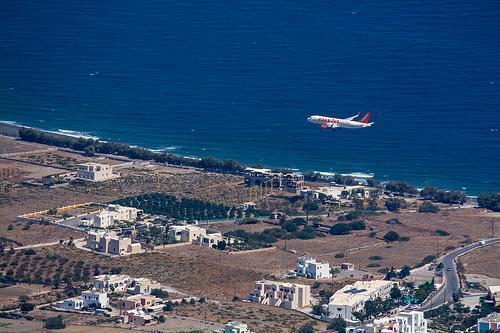How many people appear in this picture?
Give a very brief answer. 0. How many planes are in the picture?
Give a very brief answer. 1. 